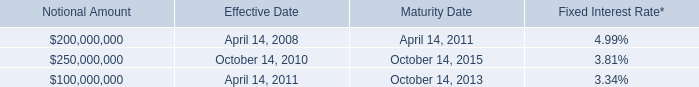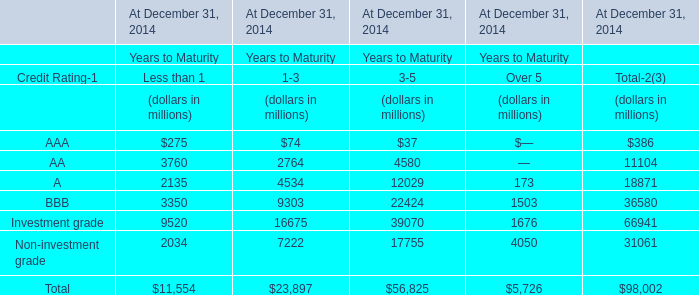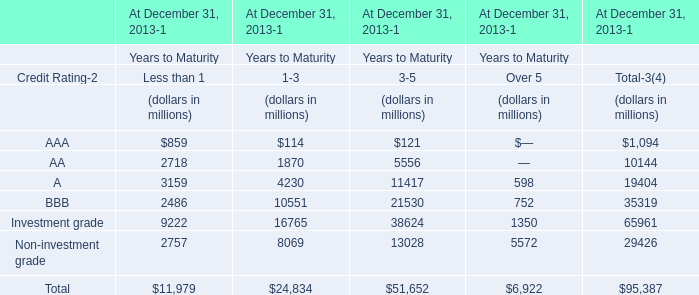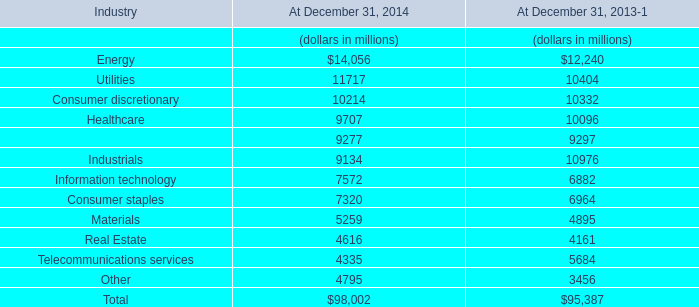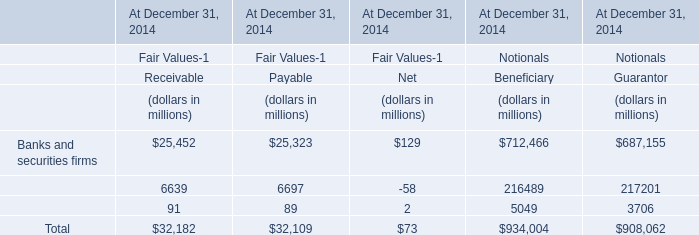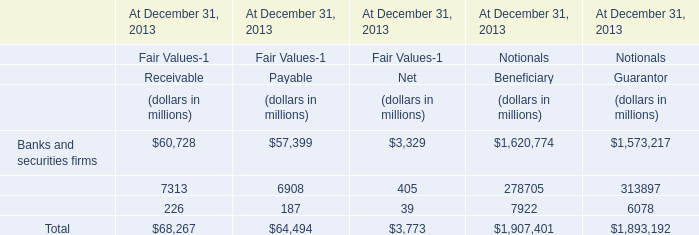What is the proportion of all elements that are greater than 5000 to the total amount of elements, for 3-5? 
Computations: ((((5556 + 11417) + 21530) + 13028) / 51652)
Answer: 0.99766. 